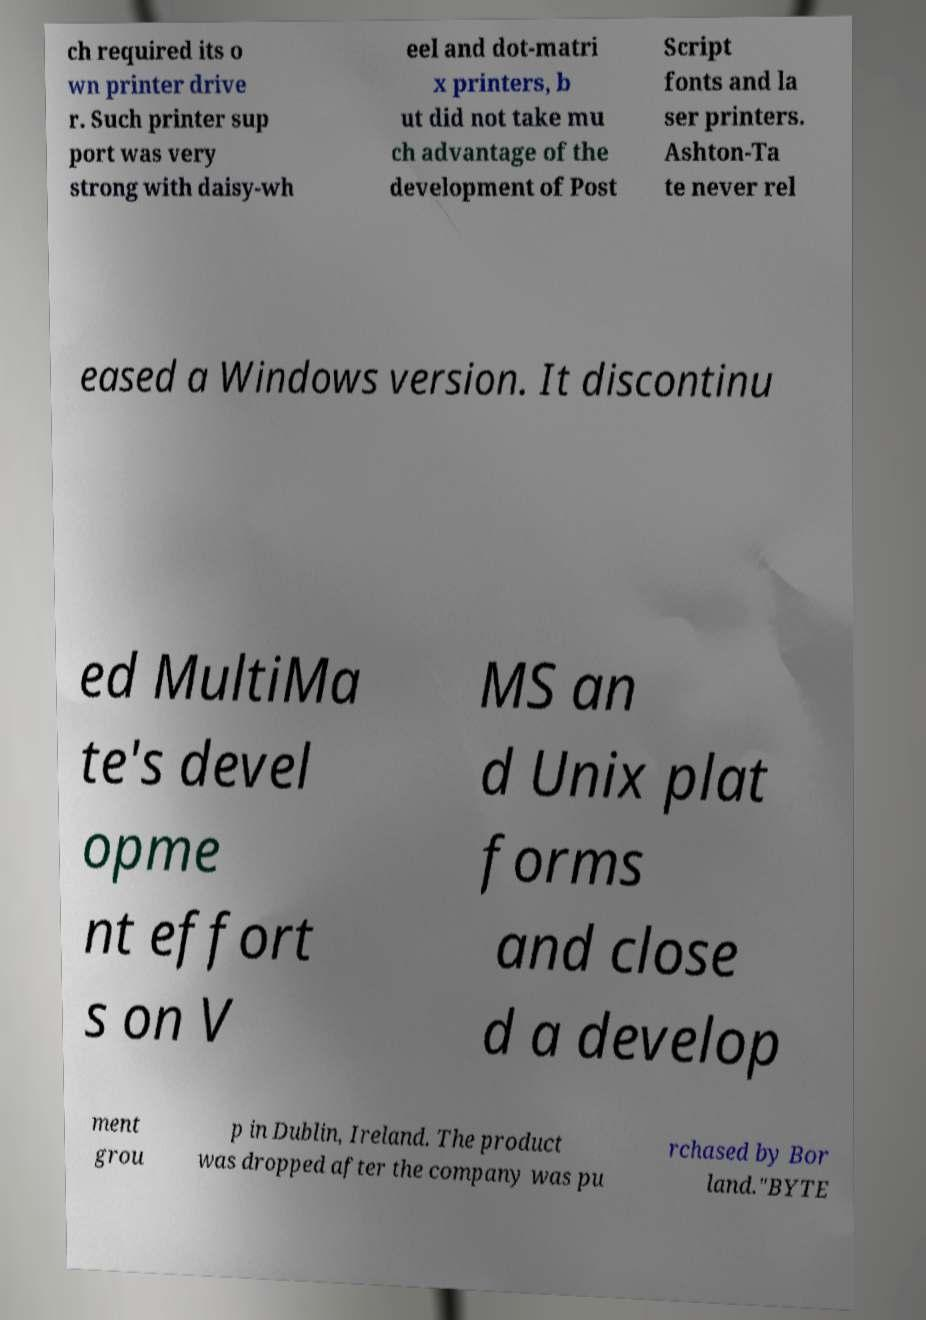Can you accurately transcribe the text from the provided image for me? ch required its o wn printer drive r. Such printer sup port was very strong with daisy-wh eel and dot-matri x printers, b ut did not take mu ch advantage of the development of Post Script fonts and la ser printers. Ashton-Ta te never rel eased a Windows version. It discontinu ed MultiMa te's devel opme nt effort s on V MS an d Unix plat forms and close d a develop ment grou p in Dublin, Ireland. The product was dropped after the company was pu rchased by Bor land."BYTE 